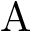<formula> <loc_0><loc_0><loc_500><loc_500>A</formula> 